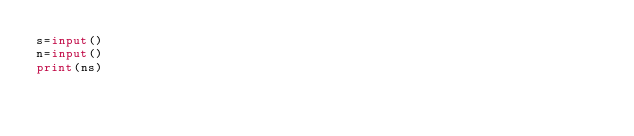Convert code to text. <code><loc_0><loc_0><loc_500><loc_500><_Python_>s=input()
n=input()
print(ns)</code> 